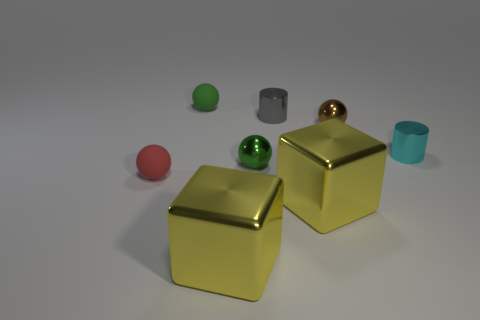Add 1 small red things. How many objects exist? 9 Subtract all blocks. How many objects are left? 6 Subtract 0 brown blocks. How many objects are left? 8 Subtract all tiny brown cylinders. Subtract all balls. How many objects are left? 4 Add 4 big yellow metal objects. How many big yellow metal objects are left? 6 Add 8 small green spheres. How many small green spheres exist? 10 